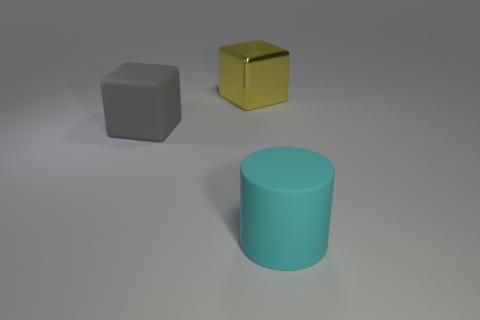Is there anything else that is made of the same material as the yellow cube?
Make the answer very short. No. There is a object that is both in front of the yellow metal cube and behind the cylinder; what is its size?
Ensure brevity in your answer.  Large. What shape is the other thing that is made of the same material as the big gray thing?
Your answer should be compact. Cylinder. Is the cylinder made of the same material as the thing that is on the left side of the large yellow object?
Keep it short and to the point. Yes. There is a rubber object to the left of the large cyan cylinder; is there a big thing that is behind it?
Ensure brevity in your answer.  Yes. What is the material of the yellow object that is the same shape as the large gray matte object?
Your answer should be compact. Metal. How many gray matte cubes are in front of the rubber object that is left of the rubber cylinder?
Provide a succinct answer. 0. Is there anything else that has the same color as the large matte block?
Provide a succinct answer. No. What number of things are either small gray matte balls or large blocks that are to the right of the large gray matte thing?
Offer a terse response. 1. What material is the large object that is in front of the large matte object to the left of the object that is on the right side of the large yellow metallic object made of?
Offer a terse response. Rubber. 